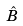Convert formula to latex. <formula><loc_0><loc_0><loc_500><loc_500>\hat { B }</formula> 